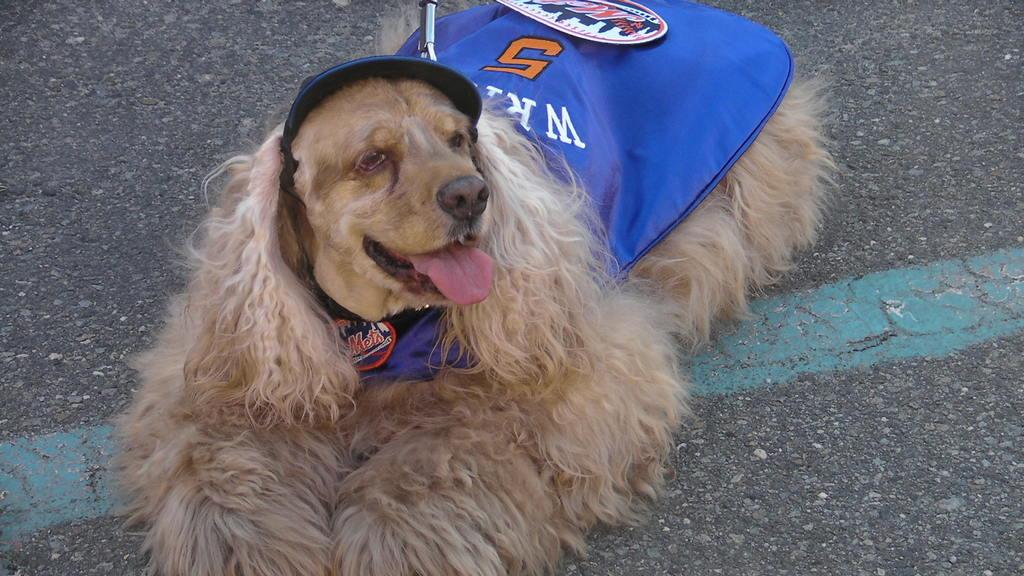What animal can be seen in the image? There is a dog in the image. What is the dog doing in the image? The dog is laying on the road. What type of paint is being used to create the airplane in the image? There is no airplane present in the image, so there is no paint being used for it. 